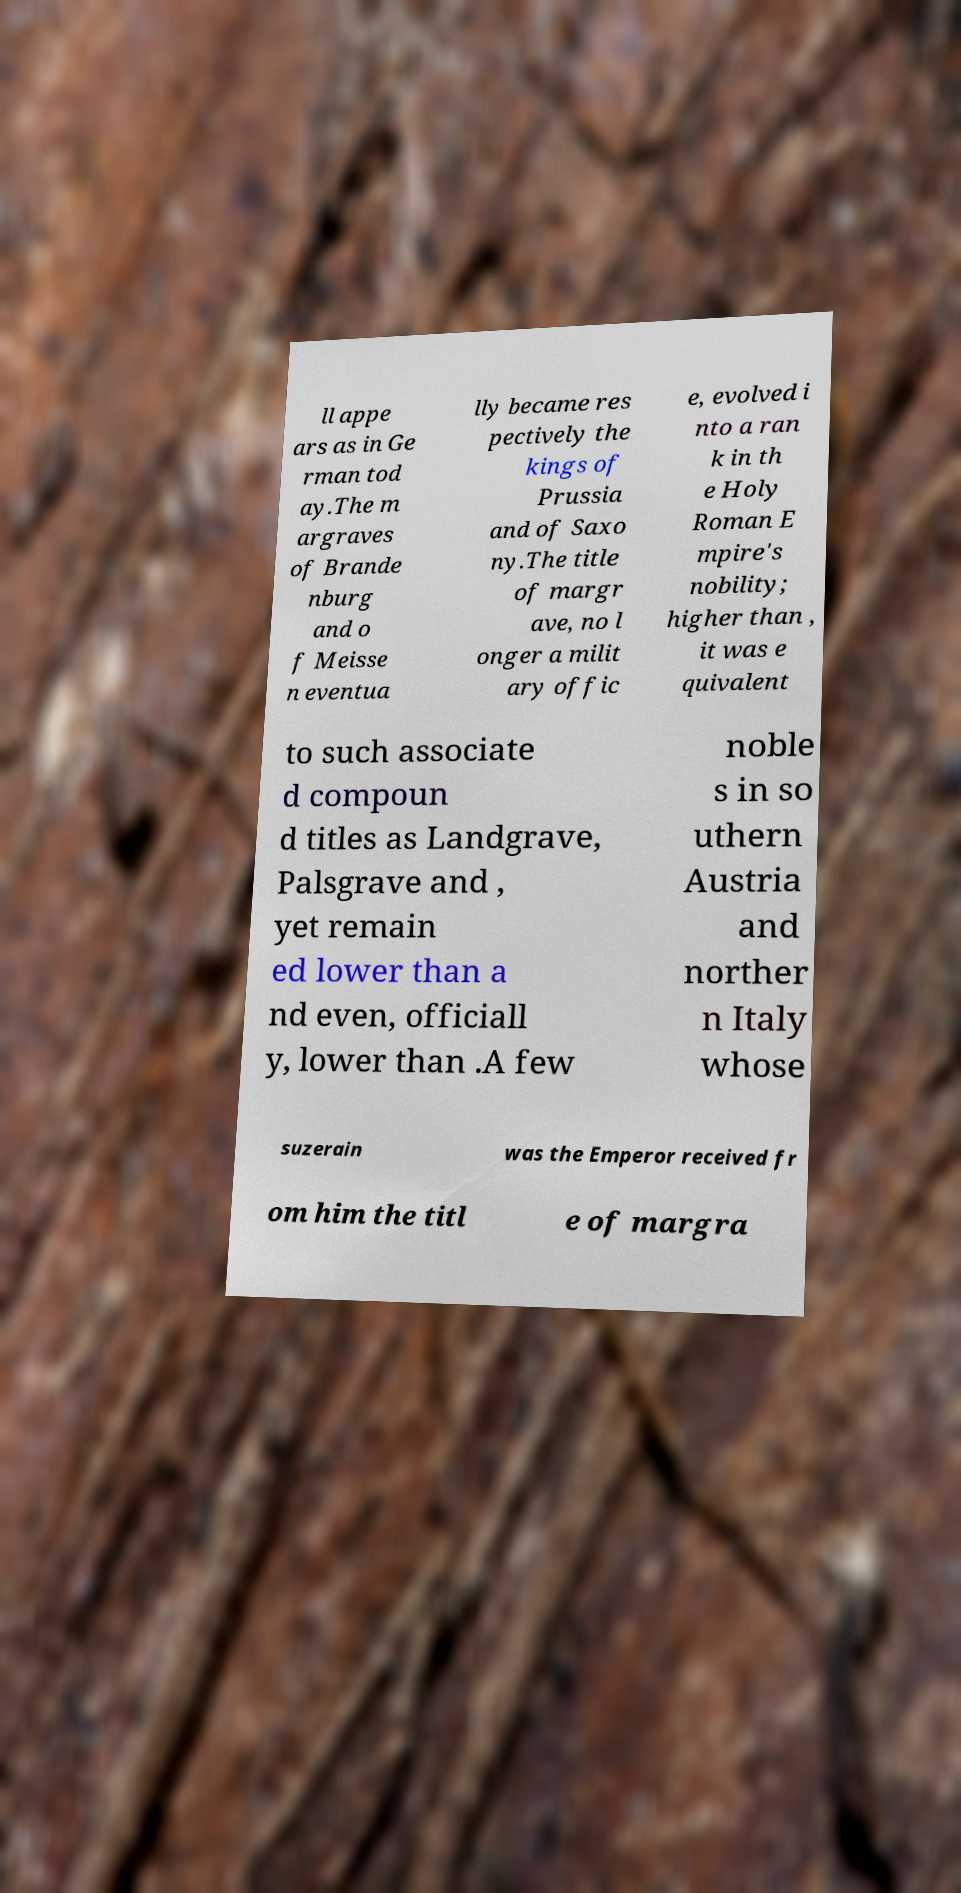Could you assist in decoding the text presented in this image and type it out clearly? ll appe ars as in Ge rman tod ay.The m argraves of Brande nburg and o f Meisse n eventua lly became res pectively the kings of Prussia and of Saxo ny.The title of margr ave, no l onger a milit ary offic e, evolved i nto a ran k in th e Holy Roman E mpire's nobility; higher than , it was e quivalent to such associate d compoun d titles as Landgrave, Palsgrave and , yet remain ed lower than a nd even, officiall y, lower than .A few noble s in so uthern Austria and norther n Italy whose suzerain was the Emperor received fr om him the titl e of margra 